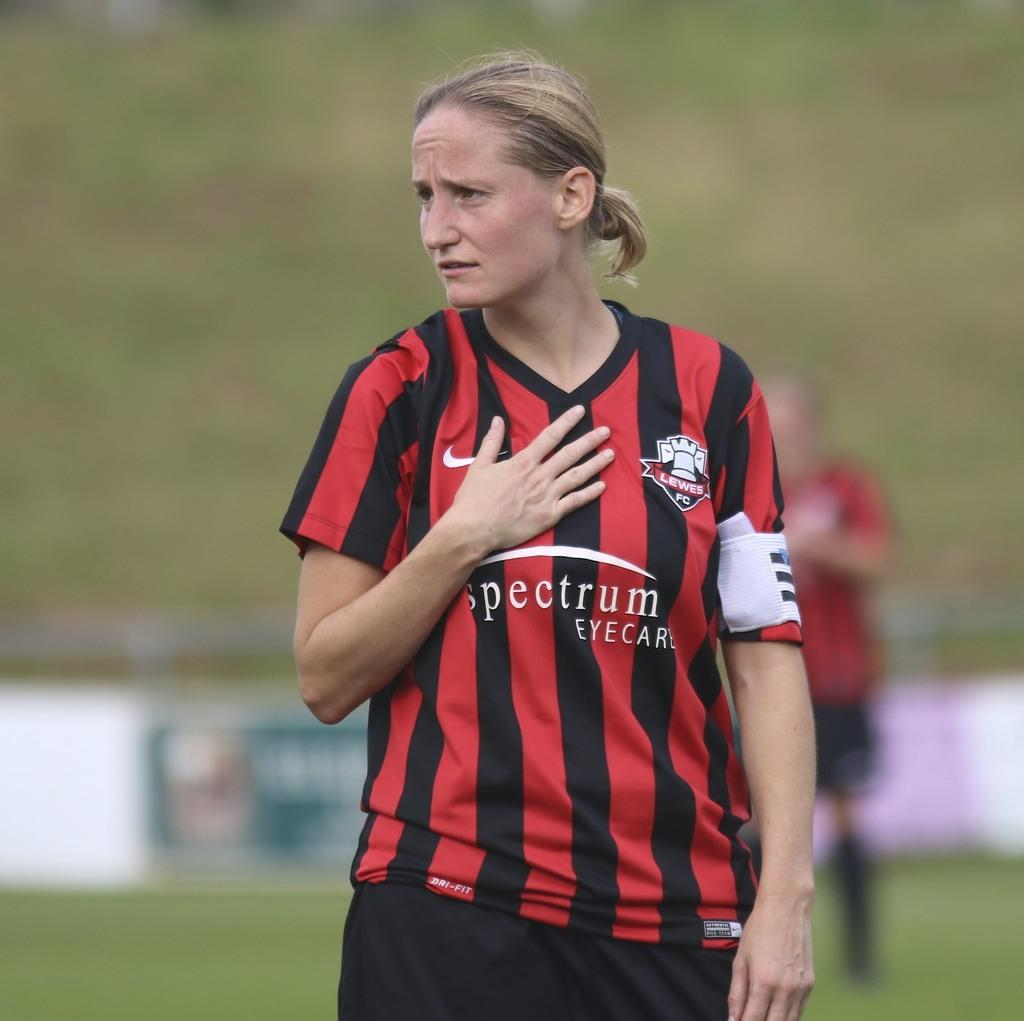<image>
Provide a brief description of the given image. Soccer player wearing a red and black shirt that says Spectrum on it. 